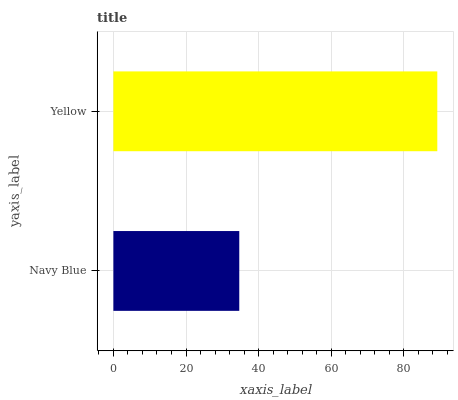Is Navy Blue the minimum?
Answer yes or no. Yes. Is Yellow the maximum?
Answer yes or no. Yes. Is Yellow the minimum?
Answer yes or no. No. Is Yellow greater than Navy Blue?
Answer yes or no. Yes. Is Navy Blue less than Yellow?
Answer yes or no. Yes. Is Navy Blue greater than Yellow?
Answer yes or no. No. Is Yellow less than Navy Blue?
Answer yes or no. No. Is Yellow the high median?
Answer yes or no. Yes. Is Navy Blue the low median?
Answer yes or no. Yes. Is Navy Blue the high median?
Answer yes or no. No. Is Yellow the low median?
Answer yes or no. No. 